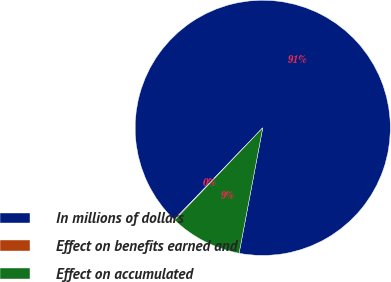Convert chart. <chart><loc_0><loc_0><loc_500><loc_500><pie_chart><fcel>In millions of dollars<fcel>Effect on benefits earned and<fcel>Effect on accumulated<nl><fcel>90.75%<fcel>0.09%<fcel>9.16%<nl></chart> 